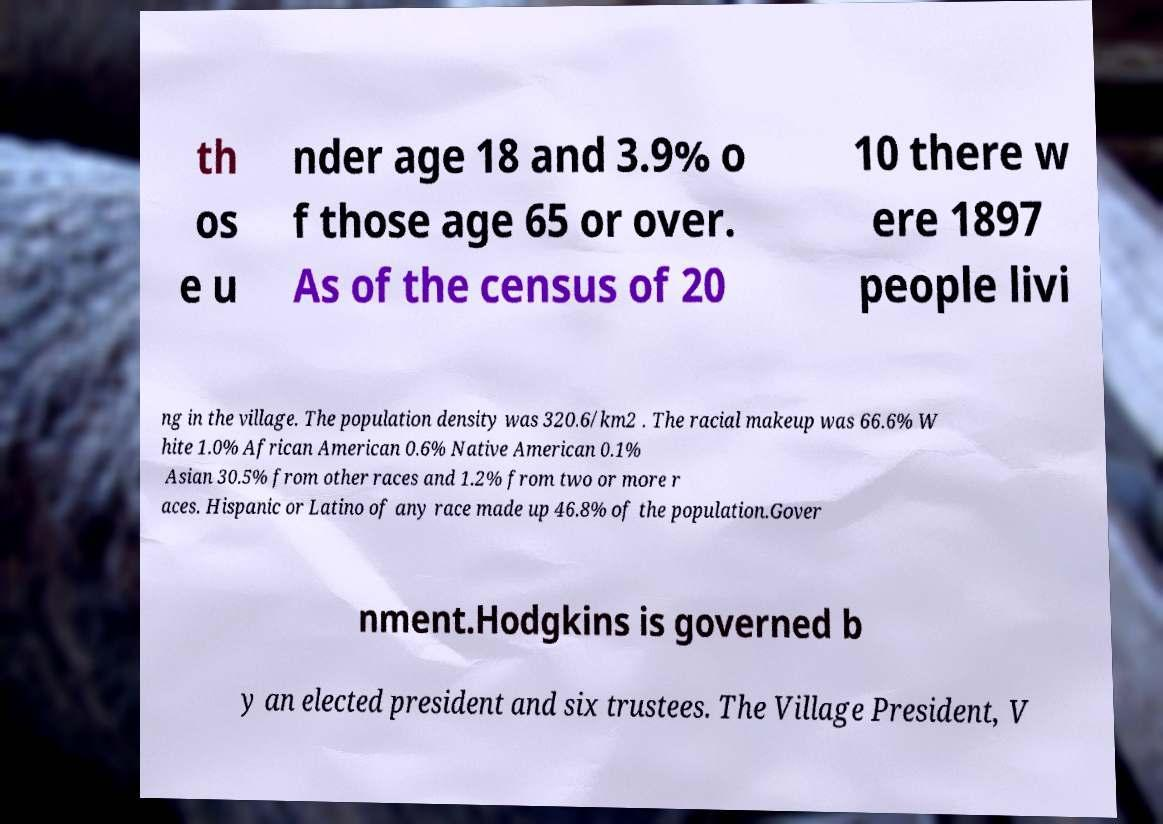Can you read and provide the text displayed in the image?This photo seems to have some interesting text. Can you extract and type it out for me? th os e u nder age 18 and 3.9% o f those age 65 or over. As of the census of 20 10 there w ere 1897 people livi ng in the village. The population density was 320.6/km2 . The racial makeup was 66.6% W hite 1.0% African American 0.6% Native American 0.1% Asian 30.5% from other races and 1.2% from two or more r aces. Hispanic or Latino of any race made up 46.8% of the population.Gover nment.Hodgkins is governed b y an elected president and six trustees. The Village President, V 